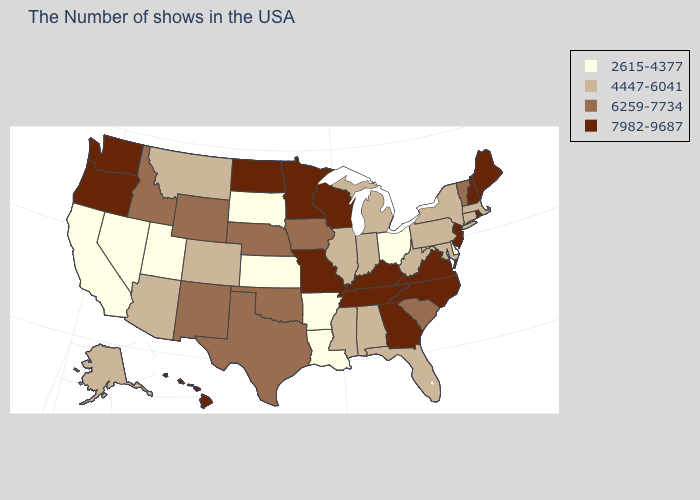Among the states that border Utah , does Nevada have the lowest value?
Answer briefly. Yes. Which states have the lowest value in the USA?
Be succinct. Delaware, Ohio, Louisiana, Arkansas, Kansas, South Dakota, Utah, Nevada, California. What is the value of Nebraska?
Short answer required. 6259-7734. Does Illinois have a higher value than Arkansas?
Keep it brief. Yes. Does Vermont have the lowest value in the USA?
Quick response, please. No. What is the lowest value in the USA?
Keep it brief. 2615-4377. Does Wyoming have the lowest value in the West?
Answer briefly. No. Name the states that have a value in the range 4447-6041?
Keep it brief. Massachusetts, Connecticut, New York, Maryland, Pennsylvania, West Virginia, Florida, Michigan, Indiana, Alabama, Illinois, Mississippi, Colorado, Montana, Arizona, Alaska. What is the value of Virginia?
Quick response, please. 7982-9687. Among the states that border California , does Arizona have the highest value?
Keep it brief. No. How many symbols are there in the legend?
Write a very short answer. 4. What is the highest value in states that border North Dakota?
Be succinct. 7982-9687. What is the value of Washington?
Answer briefly. 7982-9687. Does North Carolina have the lowest value in the USA?
Be succinct. No. Name the states that have a value in the range 2615-4377?
Concise answer only. Delaware, Ohio, Louisiana, Arkansas, Kansas, South Dakota, Utah, Nevada, California. 